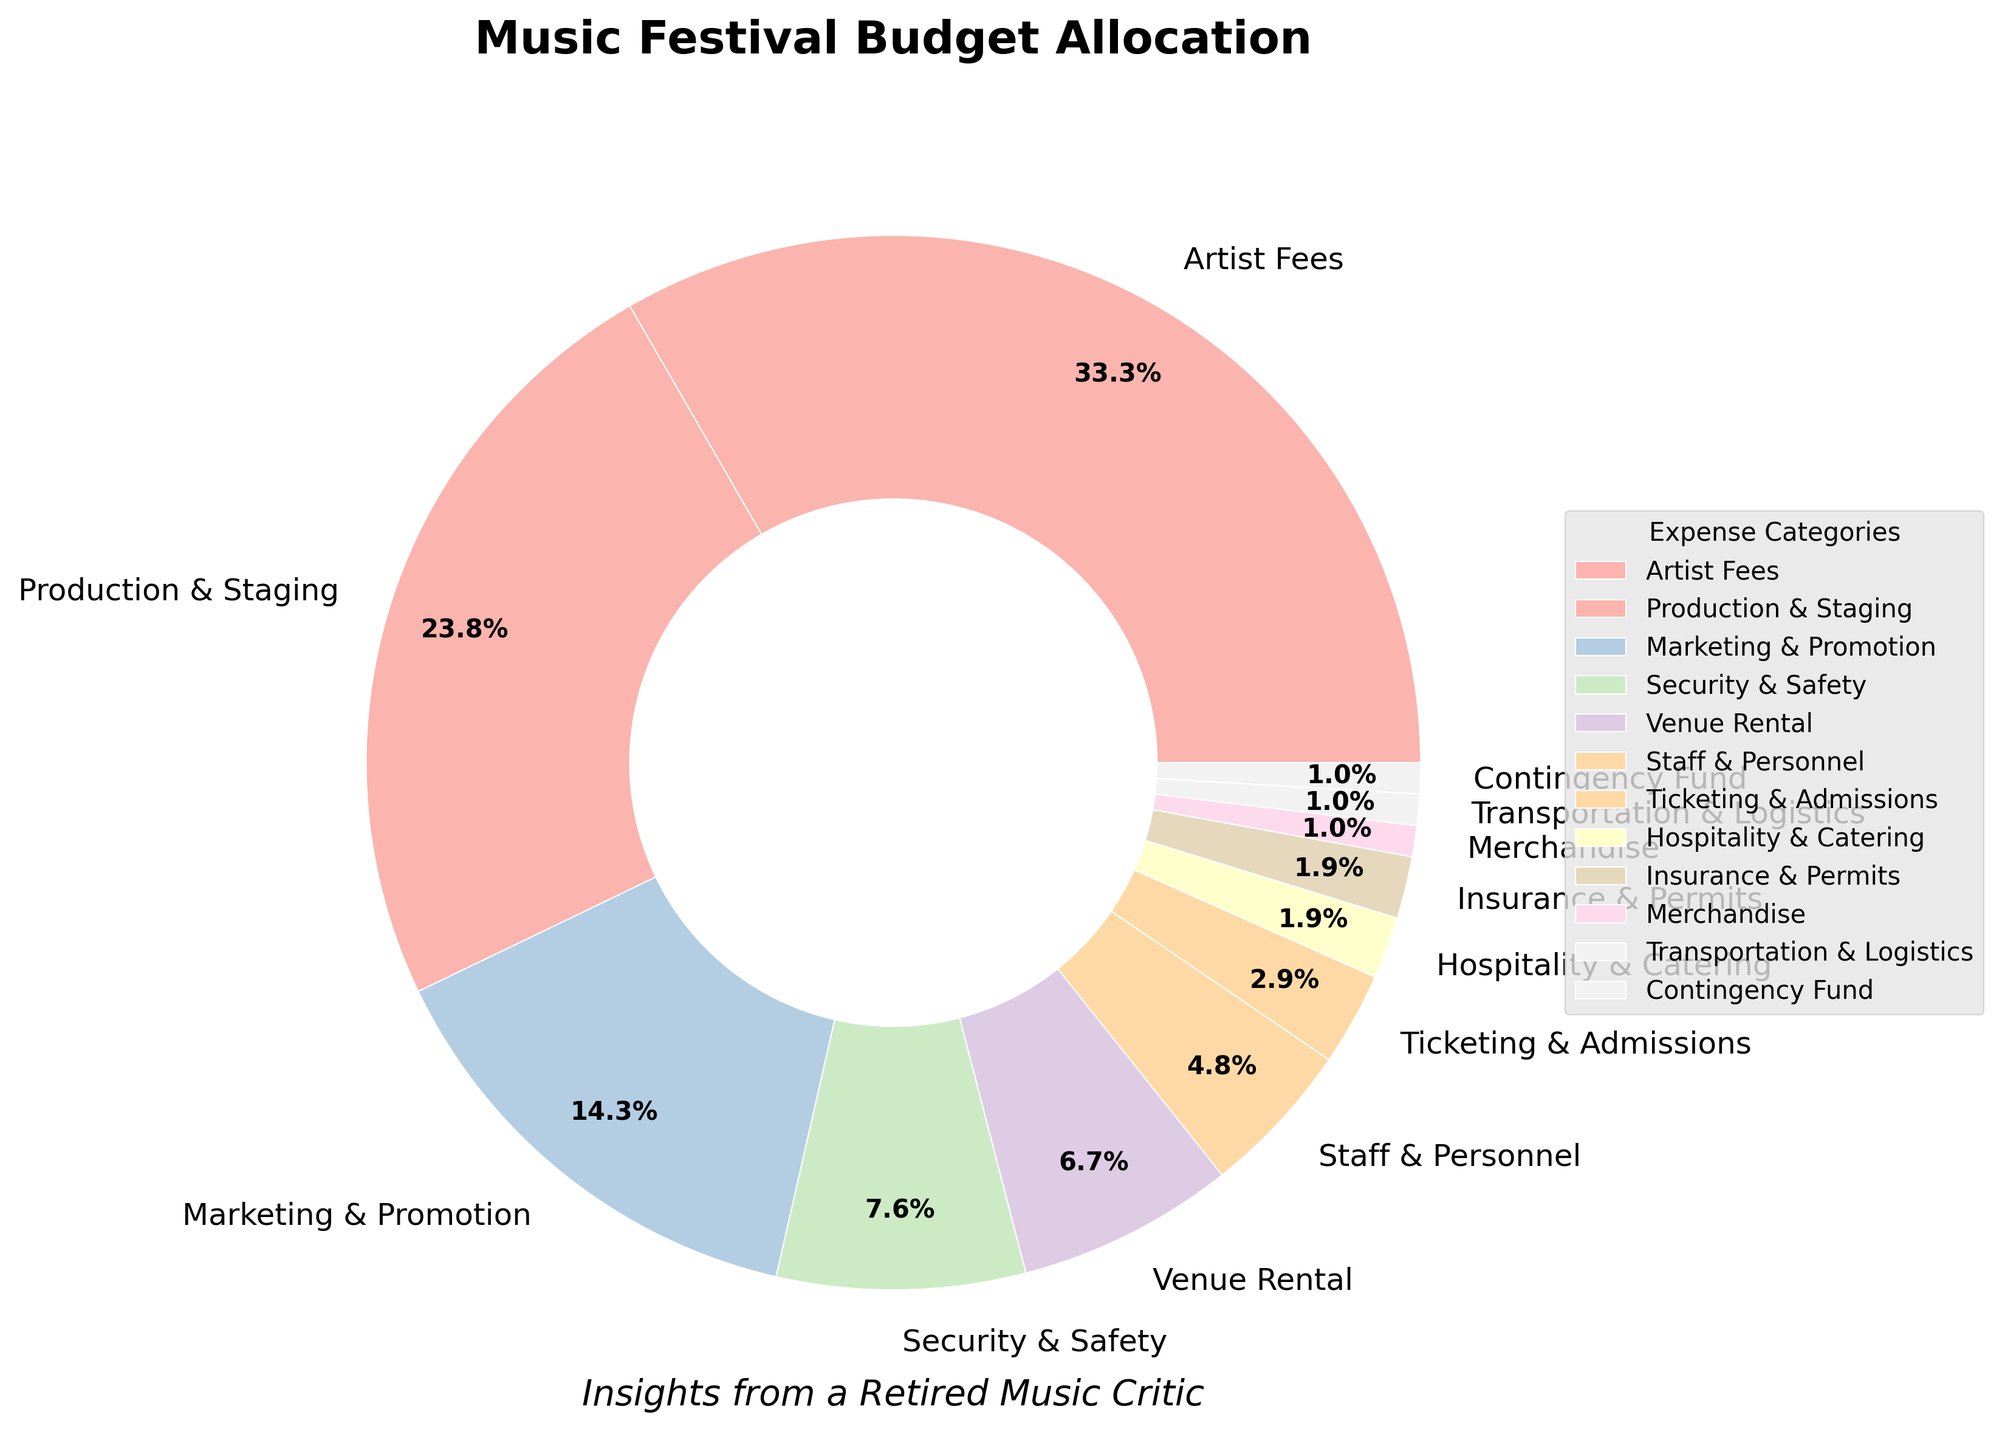1. What is the largest expense category in the music festival budget allocation? The largest expense category can be identified by looking at the category with the highest percentage in the pie chart. The segment for 'Artist Fees' takes up 35% which is the largest.
Answer: Artist Fees 2. How much of the budget is spent on both 'Marketing & Promotion' and 'Security & Safety' together? To find the combined budget for 'Marketing & Promotion' and 'Security & Safety', add their percentages. 'Marketing & Promotion' is 15% and 'Security & Safety' is 8%. So, 15% + 8% = 23%.
Answer: 23% 3. Which expense category is allocated 7% of the budget? Look for the category that corresponds to the 7% segment in the pie chart. 'Venue Rental' is allocated 7% of the budget.
Answer: Venue Rental 4. Compare the budget allocation for 'Staff & Personnel' and 'Ticketing & Admissions'. Which one receives more funding? Check the percentages for both categories. 'Staff & Personnel' has 5% whereas 'Ticketing & Admissions' has 3%. Therefore, 'Staff & Personnel' receives more funding.
Answer: Staff & Personnel 5. What is the total percentage of the budget allocated to categories that receive 2% each? To find the total percentage of the budget allocated to categories receiving 2% each, identify the categories (‘Hospitality & Catering’ and ‘Insurance & Permits’), then add their percentages: 2% + 2% = 4%.
Answer: 4% 6. By what percentage is the budget allocation for 'Production & Staging' greater than 'Marketing & Promotion'? Subtract the percentage for 'Marketing & Promotion' (15%) from 'Production & Staging' (25%). 25% - 15% = 10%.
Answer: 10% 7. If the contingency fund was doubled, what would the new allocation be? The current allocation for the contingency fund is 1%. Doubling this would lead to 1% * 2 = 2%.
Answer: 2% 8. What color represents 'Transportation & Logistics' in the pie chart? Each category has a unique color represented in the figure. 'Transportation & Logistics' is depicted with a color from the custom palette used in the plot, which would be one of the lighter pastel shades.
Answer: (depends on the coloring but use a brief description like light pink, pastel yellow, etc.) 9. How many categories in the budget allocation receive less than 5% each? Identify all categories with less than 5% allocated. These are 'Ticketing & Admissions' (3%), 'Hospitality & Catering' (2%), 'Insurance & Permits' (2%), 'Merchandise' (1%), 'Transportation & Logistics' (1%), and 'Contingency Fund' (1%). There are 6 categories.
Answer: 6 10. What is the percentage difference between the highest and the lowest budget category? The highest category 'Artist Fees' is 35% and the lowest categories ('Merchandise', 'Transportation & Logistics', 'Contingency Fund') are 1% each. The difference is 35% - 1% = 34%.
Answer: 34% 